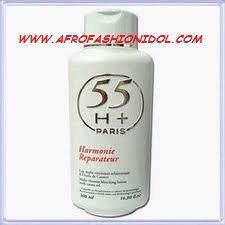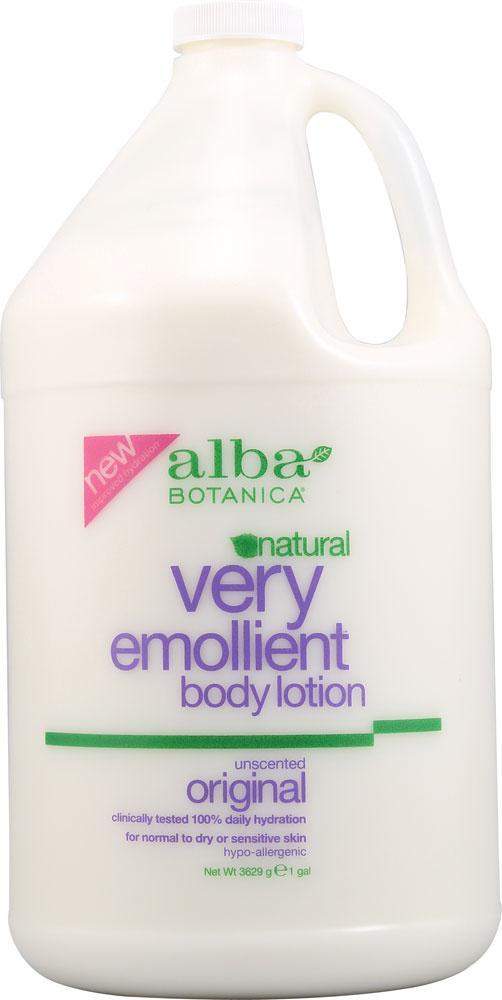The first image is the image on the left, the second image is the image on the right. Assess this claim about the two images: "Only one white bottle is squat and rectangular shaped with rounded edges and a pump top.". Correct or not? Answer yes or no. No. The first image is the image on the left, the second image is the image on the right. Assess this claim about the two images: "Left image shows a product with a pump-top dispenser.". Correct or not? Answer yes or no. No. 